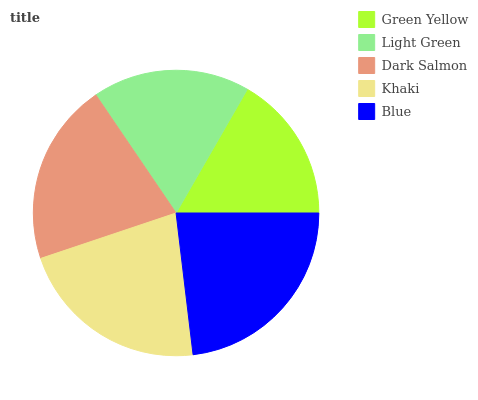Is Green Yellow the minimum?
Answer yes or no. Yes. Is Blue the maximum?
Answer yes or no. Yes. Is Light Green the minimum?
Answer yes or no. No. Is Light Green the maximum?
Answer yes or no. No. Is Light Green greater than Green Yellow?
Answer yes or no. Yes. Is Green Yellow less than Light Green?
Answer yes or no. Yes. Is Green Yellow greater than Light Green?
Answer yes or no. No. Is Light Green less than Green Yellow?
Answer yes or no. No. Is Dark Salmon the high median?
Answer yes or no. Yes. Is Dark Salmon the low median?
Answer yes or no. Yes. Is Light Green the high median?
Answer yes or no. No. Is Green Yellow the low median?
Answer yes or no. No. 